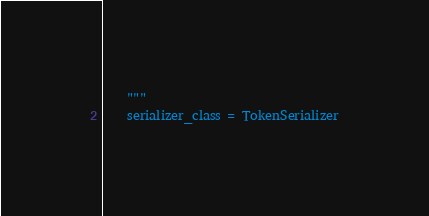Convert code to text. <code><loc_0><loc_0><loc_500><loc_500><_Python_>    """
    serializer_class = TokenSerializer
</code> 